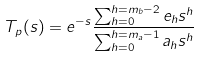<formula> <loc_0><loc_0><loc_500><loc_500>T _ { p } ( s ) = e ^ { - s } \frac { \sum _ { h = 0 } ^ { h = m _ { b } - 2 } e _ { h } s ^ { h } } { \sum _ { h = 0 } ^ { h = m _ { a } - 1 } a _ { h } s ^ { h } } \</formula> 